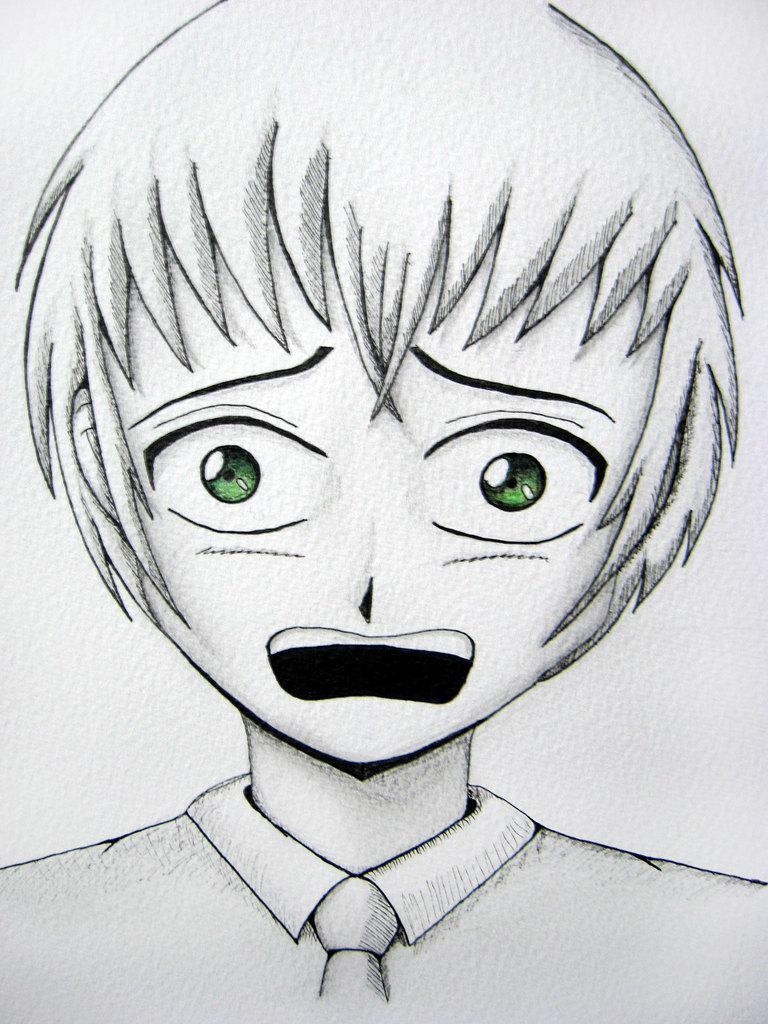Please provide a concise description of this image. This is the picture of a sketch. In this picture there is a sketch of a boy and he has green eyes. 